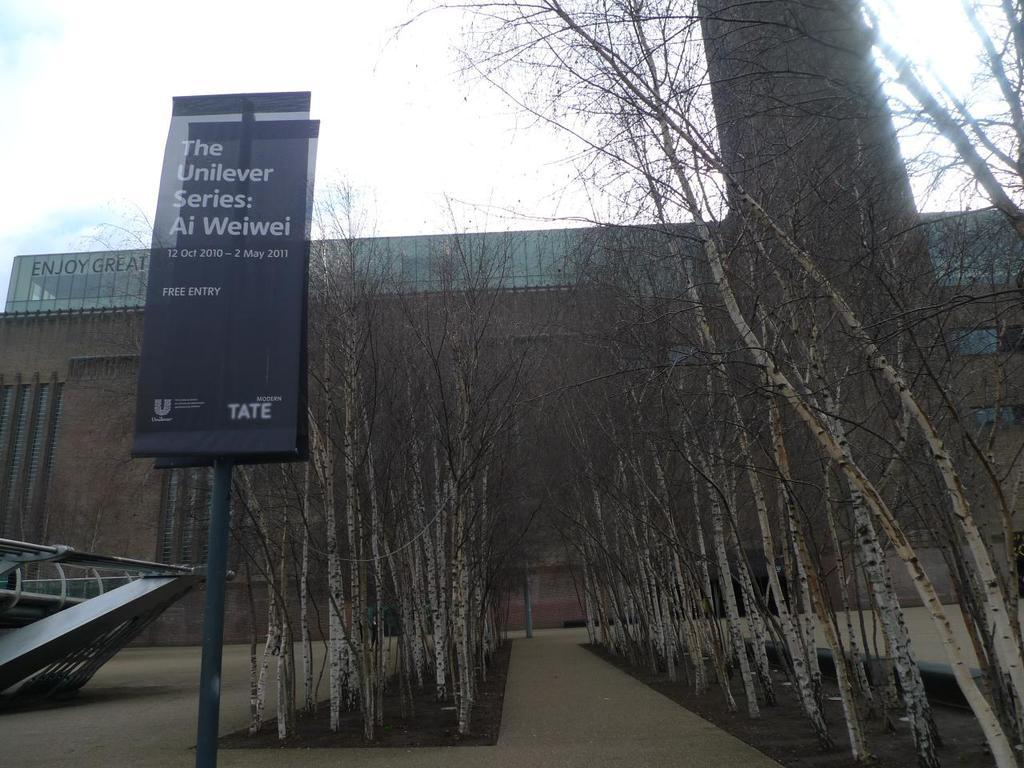What is attached to the pole in the image? There is a board attached to a pole in the image. What type of natural vegetation can be seen in the image? There are trees in the image. What type of man-made structure is visible in the image? There is a building in the image. What is visible in the background of the image? The sky is visible in the background of the image. What can be observed in the sky? Clouds are present in the sky. How many police officers are visible in the image? There are no police officers present in the image. What type of shelf or unit can be seen in the image? There is no shelf or unit present in the image. 